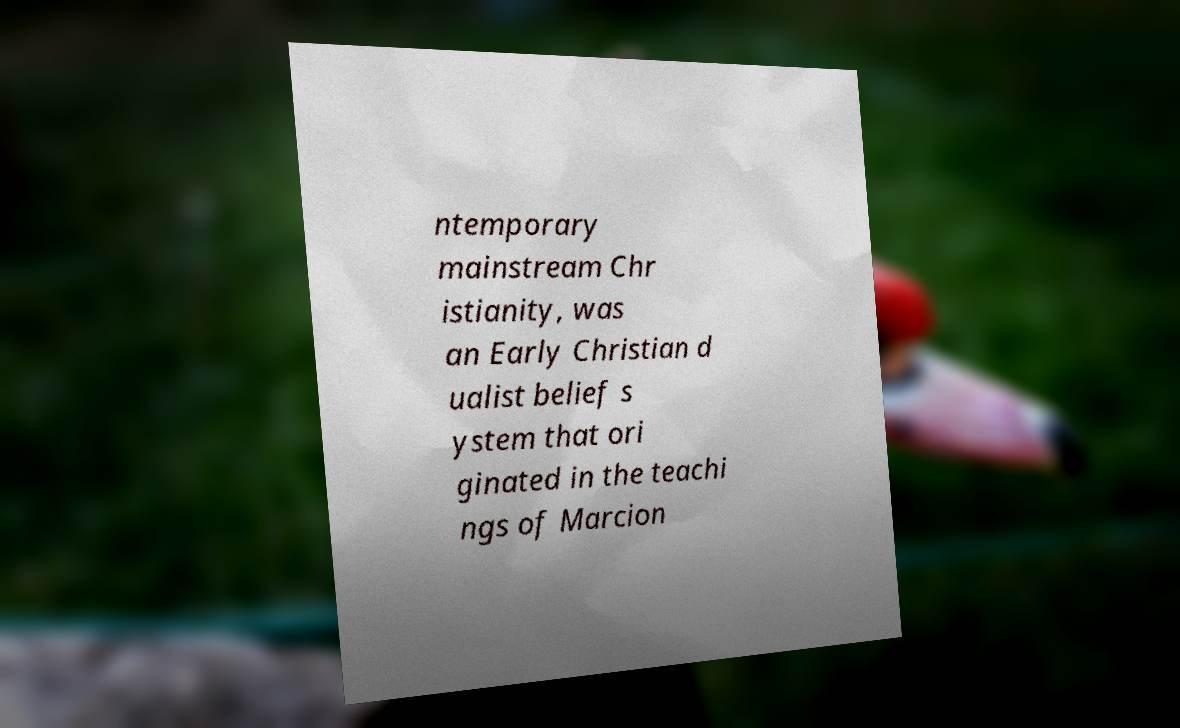Please read and relay the text visible in this image. What does it say? ntemporary mainstream Chr istianity, was an Early Christian d ualist belief s ystem that ori ginated in the teachi ngs of Marcion 